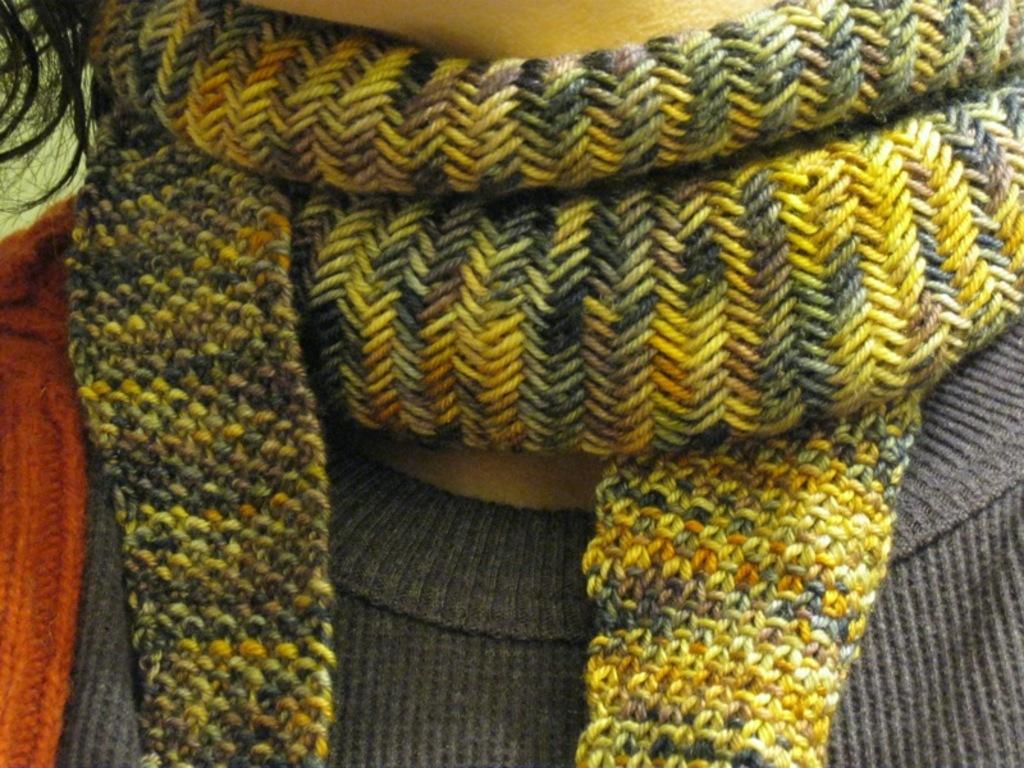Could you give a brief overview of what you see in this image? In this image there is a person wearing a woolen scarf and a woolen shirt. 